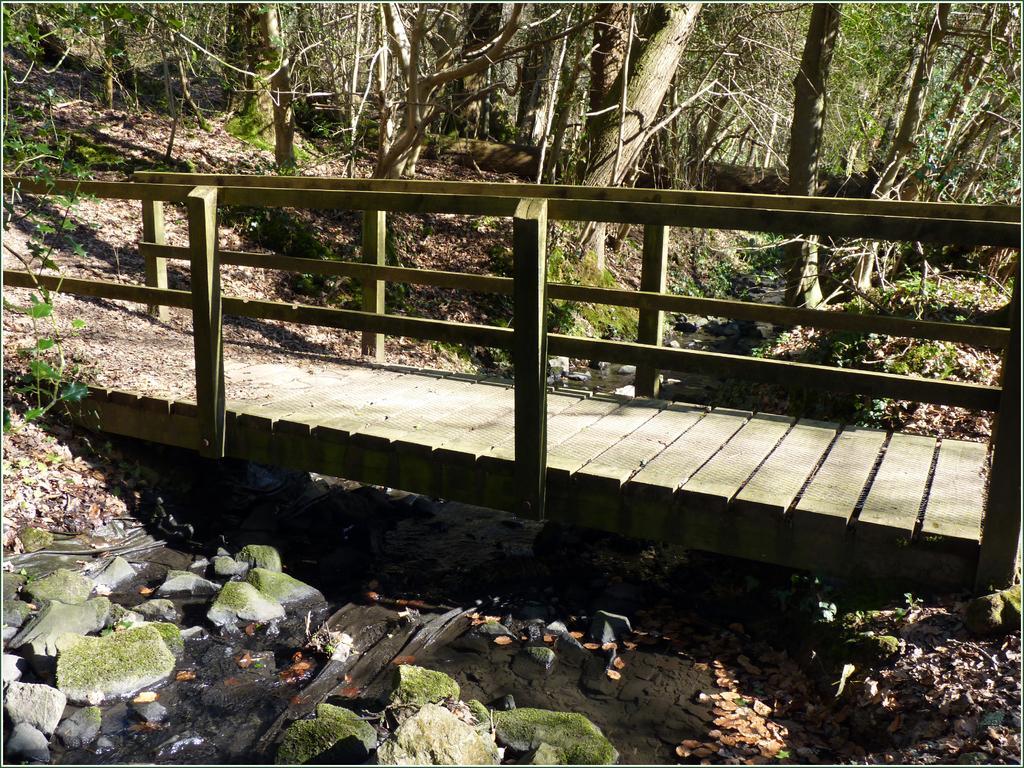Please provide a concise description of this image. In this picture I can see the bridge in front and I see number of stones. In the background I see number of trees. 